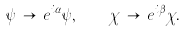Convert formula to latex. <formula><loc_0><loc_0><loc_500><loc_500>\psi \, \to \, e ^ { i \alpha } \psi , \quad \chi \, \to \, e ^ { i \beta } \chi .</formula> 